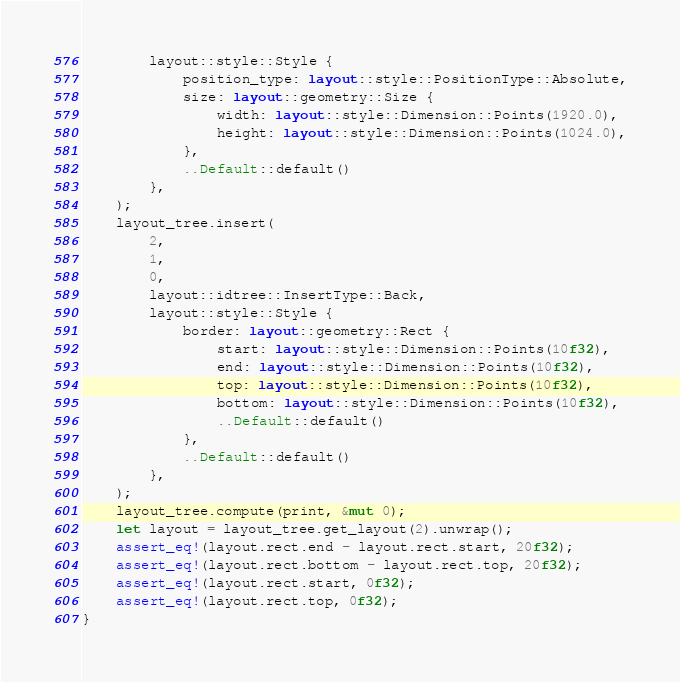Convert code to text. <code><loc_0><loc_0><loc_500><loc_500><_Rust_>        layout::style::Style {
            position_type: layout::style::PositionType::Absolute,
            size: layout::geometry::Size {
                width: layout::style::Dimension::Points(1920.0),
                height: layout::style::Dimension::Points(1024.0),
            },
            ..Default::default()
        },
    );
    layout_tree.insert(
        2,
        1,
        0,
        layout::idtree::InsertType::Back,
        layout::style::Style {
            border: layout::geometry::Rect {
                start: layout::style::Dimension::Points(10f32),
                end: layout::style::Dimension::Points(10f32),
                top: layout::style::Dimension::Points(10f32),
                bottom: layout::style::Dimension::Points(10f32),
                ..Default::default()
            },
            ..Default::default()
        },
    );
    layout_tree.compute(print, &mut 0);
    let layout = layout_tree.get_layout(2).unwrap();
    assert_eq!(layout.rect.end - layout.rect.start, 20f32);
    assert_eq!(layout.rect.bottom - layout.rect.top, 20f32);
    assert_eq!(layout.rect.start, 0f32);
    assert_eq!(layout.rect.top, 0f32);
}
</code> 